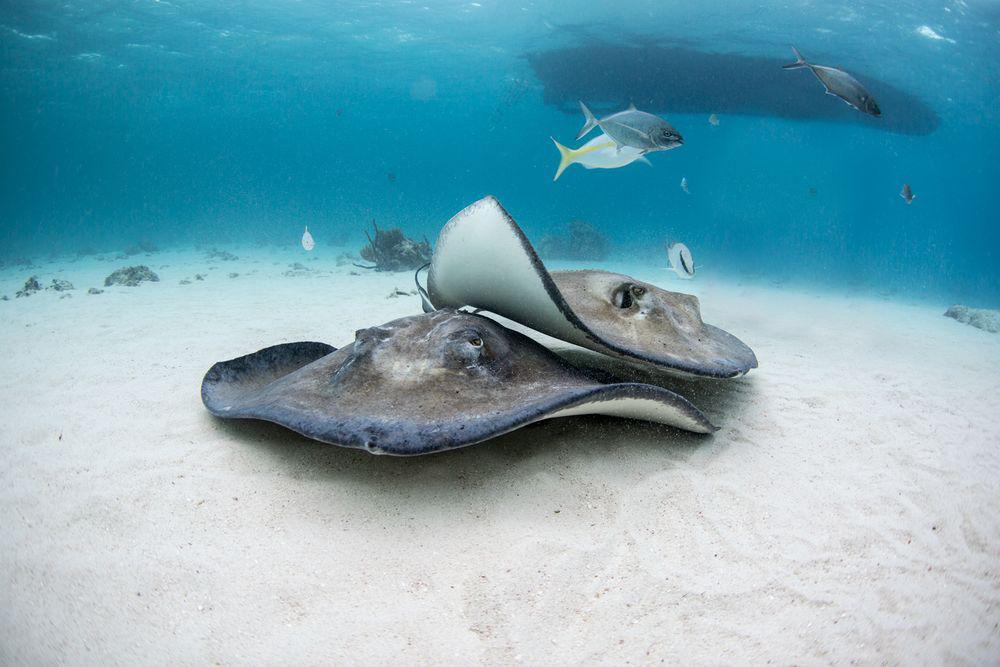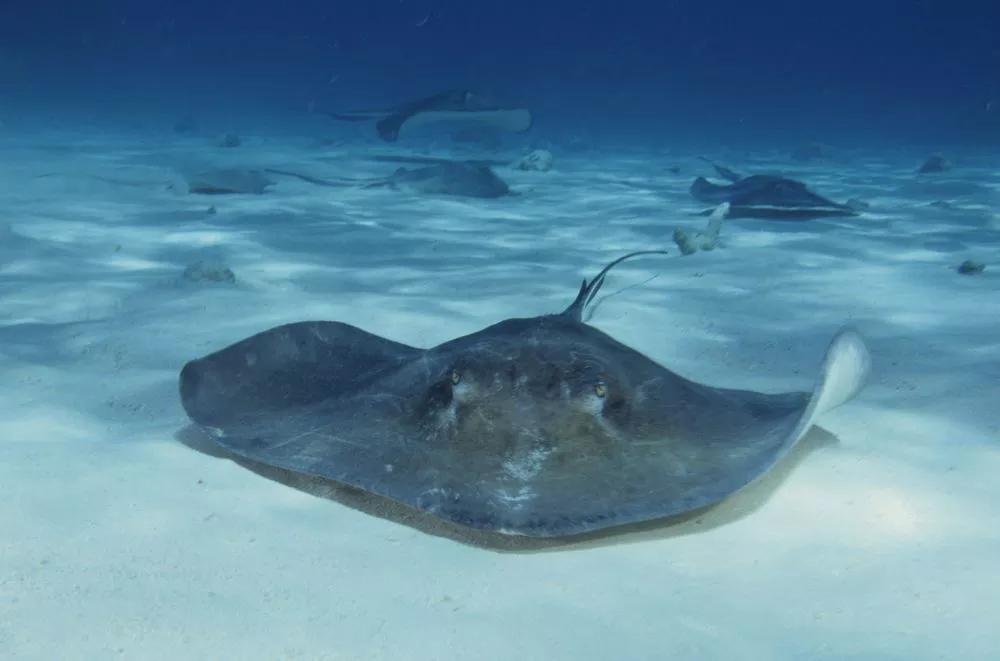The first image is the image on the left, the second image is the image on the right. Given the left and right images, does the statement "There is at least one image of a sting ray over the sand that is in front of a diver who is swimming." hold true? Answer yes or no. No. The first image is the image on the left, the second image is the image on the right. Given the left and right images, does the statement "There are exactly two scuba divers." hold true? Answer yes or no. No. 